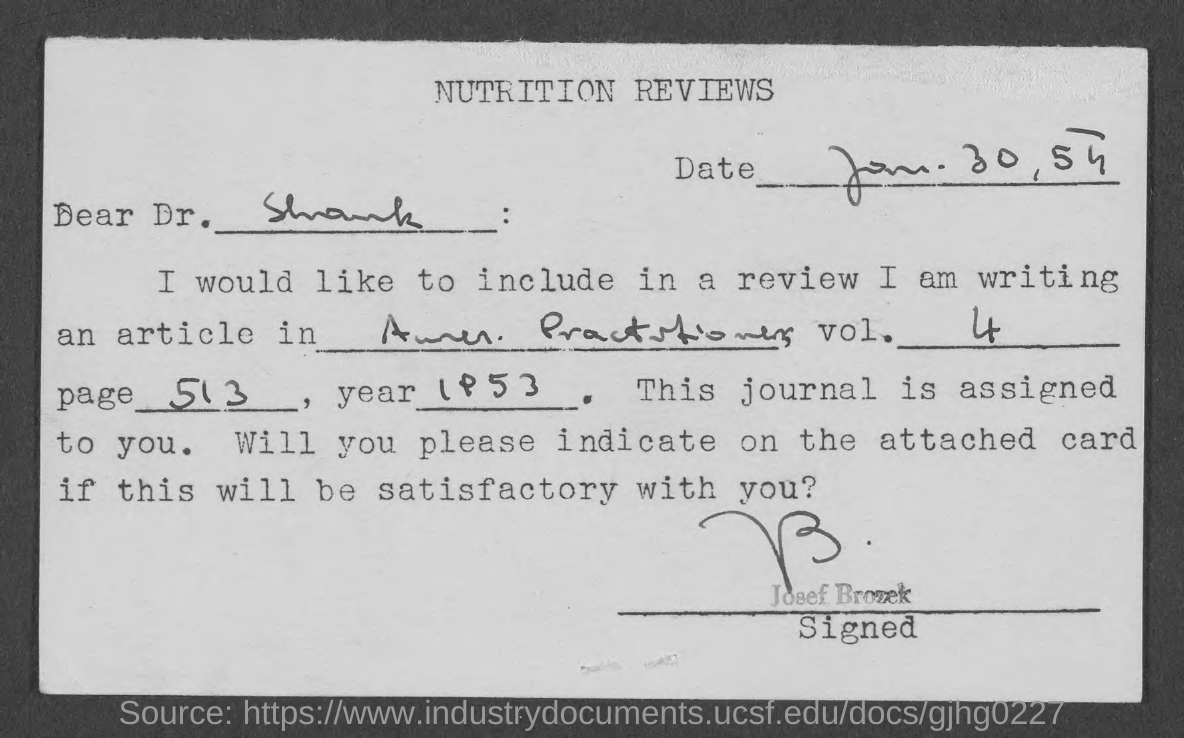What is the heading of the page?
Offer a very short reply. Nutrition Reviews. Who signed this letter?
Provide a succinct answer. Josef Brozek. 